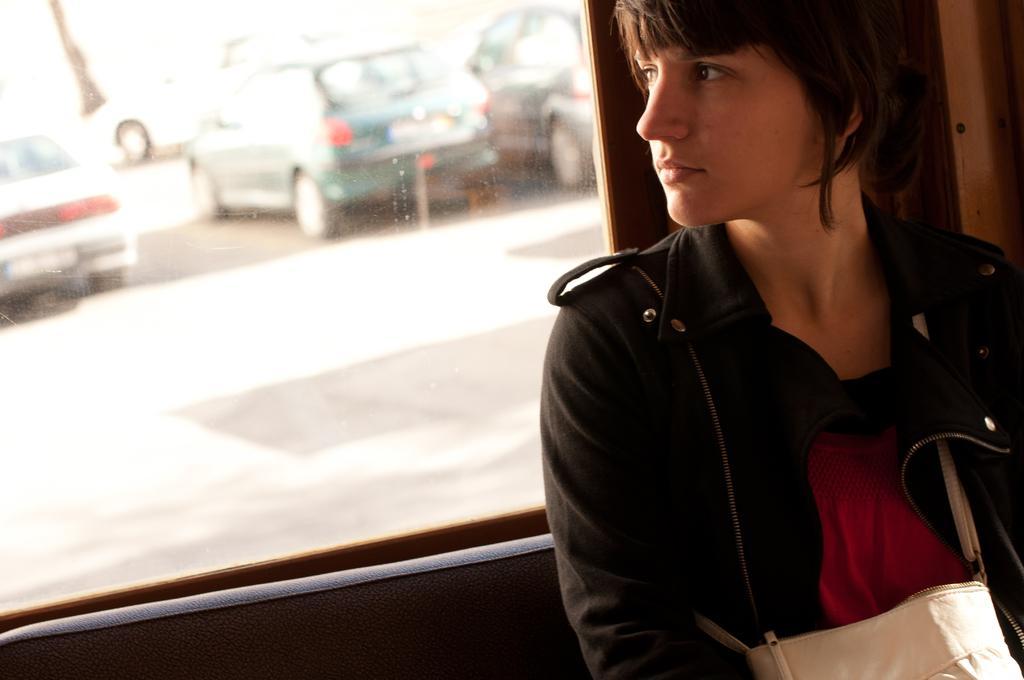Can you describe this image briefly? The woman in black jacket is highlighted in this picture. From this window we can able to see a vehicles on road. 